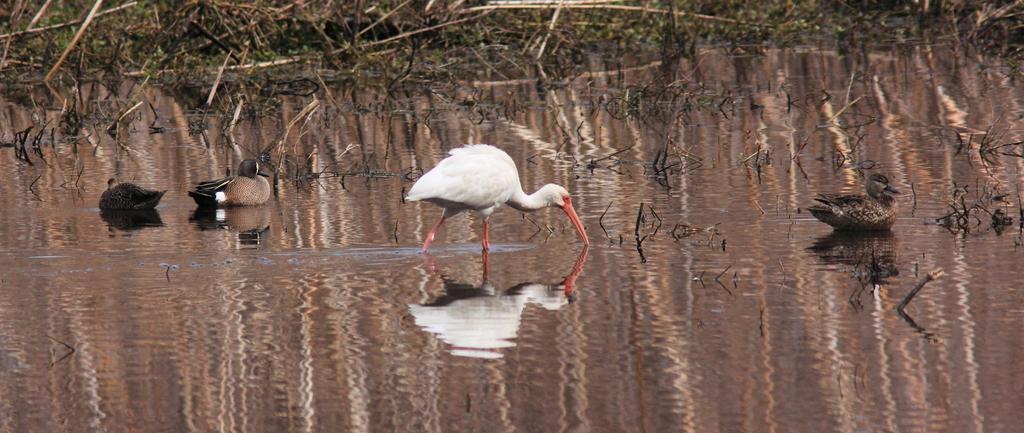Could you give a brief overview of what you see in this image? As we can see in the image there is grass, water and birds. 